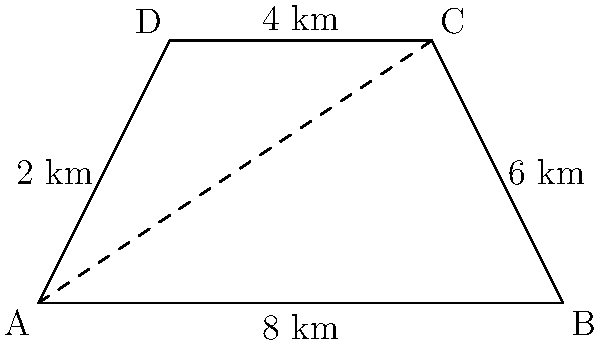A proposed land development project is represented by a trapezoid ABCD. The parallel sides AD and BC measure 2 km and 6 km respectively, while the height of the trapezoid is 4 km. What is the total area of the proposed development in square kilometers? To calculate the area of a trapezoid, we can use the formula:

$$A = \frac{1}{2}(b_1 + b_2)h$$

Where:
$A$ is the area
$b_1$ and $b_2$ are the lengths of the parallel sides
$h$ is the height of the trapezoid

Given:
$b_1 = 2$ km (length of AD)
$b_2 = 6$ km (length of BC)
$h = 4$ km (height of the trapezoid)

Let's substitute these values into the formula:

$$A = \frac{1}{2}(2 + 6) \times 4$$
$$A = \frac{1}{2}(8) \times 4$$
$$A = 4 \times 4$$
$$A = 16$$

Therefore, the total area of the proposed development is 16 square kilometers.
Answer: 16 km² 